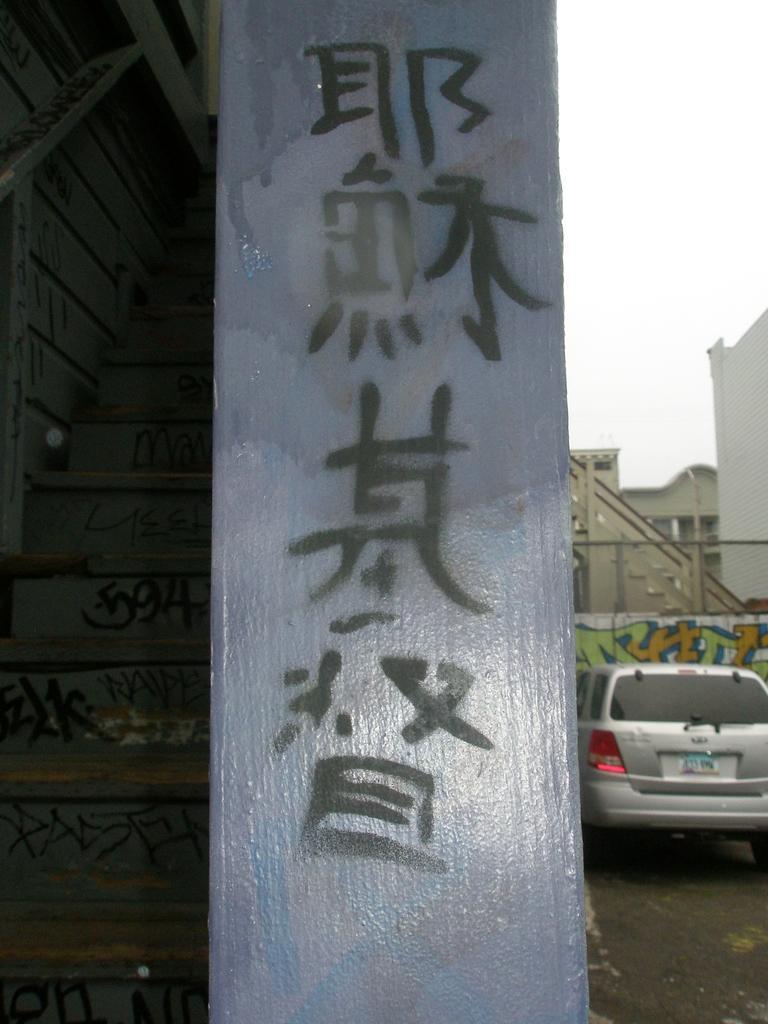How would you summarize this image in a sentence or two? In this image in the foreground there is a pole, here there is a car. In the background there are buildings. 